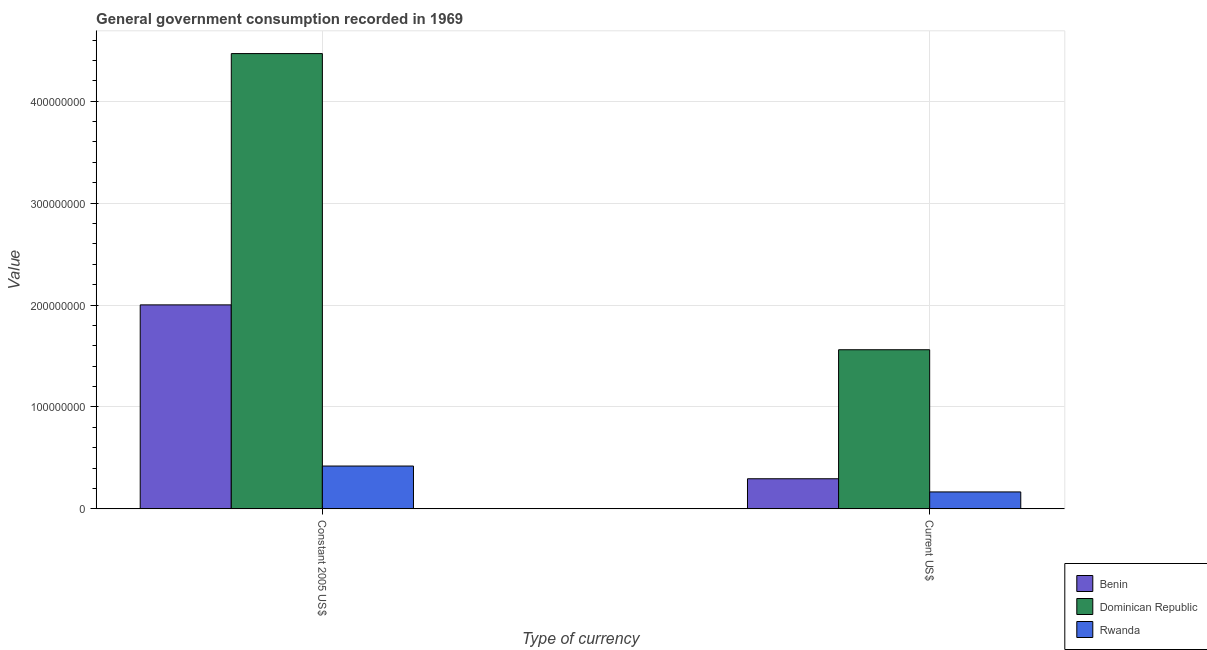How many different coloured bars are there?
Provide a short and direct response. 3. How many bars are there on the 2nd tick from the left?
Keep it short and to the point. 3. What is the label of the 1st group of bars from the left?
Ensure brevity in your answer.  Constant 2005 US$. What is the value consumed in current us$ in Dominican Republic?
Offer a terse response. 1.56e+08. Across all countries, what is the maximum value consumed in constant 2005 us$?
Ensure brevity in your answer.  4.47e+08. Across all countries, what is the minimum value consumed in current us$?
Give a very brief answer. 1.66e+07. In which country was the value consumed in constant 2005 us$ maximum?
Your response must be concise. Dominican Republic. In which country was the value consumed in current us$ minimum?
Keep it short and to the point. Rwanda. What is the total value consumed in current us$ in the graph?
Your response must be concise. 2.02e+08. What is the difference between the value consumed in constant 2005 us$ in Rwanda and that in Dominican Republic?
Keep it short and to the point. -4.05e+08. What is the difference between the value consumed in constant 2005 us$ in Rwanda and the value consumed in current us$ in Dominican Republic?
Your answer should be compact. -1.14e+08. What is the average value consumed in constant 2005 us$ per country?
Your answer should be compact. 2.30e+08. What is the difference between the value consumed in constant 2005 us$ and value consumed in current us$ in Benin?
Provide a short and direct response. 1.71e+08. What is the ratio of the value consumed in constant 2005 us$ in Benin to that in Dominican Republic?
Provide a short and direct response. 0.45. In how many countries, is the value consumed in constant 2005 us$ greater than the average value consumed in constant 2005 us$ taken over all countries?
Provide a succinct answer. 1. What does the 1st bar from the left in Current US$ represents?
Ensure brevity in your answer.  Benin. What does the 1st bar from the right in Constant 2005 US$ represents?
Keep it short and to the point. Rwanda. How many bars are there?
Ensure brevity in your answer.  6. Are the values on the major ticks of Y-axis written in scientific E-notation?
Your answer should be compact. No. Does the graph contain any zero values?
Your answer should be very brief. No. Does the graph contain grids?
Give a very brief answer. Yes. Where does the legend appear in the graph?
Keep it short and to the point. Bottom right. How many legend labels are there?
Ensure brevity in your answer.  3. What is the title of the graph?
Offer a terse response. General government consumption recorded in 1969. What is the label or title of the X-axis?
Offer a terse response. Type of currency. What is the label or title of the Y-axis?
Provide a short and direct response. Value. What is the Value of Benin in Constant 2005 US$?
Make the answer very short. 2.00e+08. What is the Value in Dominican Republic in Constant 2005 US$?
Provide a succinct answer. 4.47e+08. What is the Value in Rwanda in Constant 2005 US$?
Ensure brevity in your answer.  4.20e+07. What is the Value in Benin in Current US$?
Offer a terse response. 2.95e+07. What is the Value in Dominican Republic in Current US$?
Your answer should be very brief. 1.56e+08. What is the Value in Rwanda in Current US$?
Your answer should be compact. 1.66e+07. Across all Type of currency, what is the maximum Value in Benin?
Your answer should be compact. 2.00e+08. Across all Type of currency, what is the maximum Value in Dominican Republic?
Offer a very short reply. 4.47e+08. Across all Type of currency, what is the maximum Value in Rwanda?
Your response must be concise. 4.20e+07. Across all Type of currency, what is the minimum Value of Benin?
Provide a succinct answer. 2.95e+07. Across all Type of currency, what is the minimum Value in Dominican Republic?
Give a very brief answer. 1.56e+08. Across all Type of currency, what is the minimum Value in Rwanda?
Your response must be concise. 1.66e+07. What is the total Value in Benin in the graph?
Provide a succinct answer. 2.30e+08. What is the total Value in Dominican Republic in the graph?
Provide a short and direct response. 6.03e+08. What is the total Value of Rwanda in the graph?
Provide a short and direct response. 5.86e+07. What is the difference between the Value in Benin in Constant 2005 US$ and that in Current US$?
Your answer should be very brief. 1.71e+08. What is the difference between the Value of Dominican Republic in Constant 2005 US$ and that in Current US$?
Make the answer very short. 2.91e+08. What is the difference between the Value of Rwanda in Constant 2005 US$ and that in Current US$?
Give a very brief answer. 2.54e+07. What is the difference between the Value in Benin in Constant 2005 US$ and the Value in Dominican Republic in Current US$?
Provide a succinct answer. 4.40e+07. What is the difference between the Value in Benin in Constant 2005 US$ and the Value in Rwanda in Current US$?
Make the answer very short. 1.84e+08. What is the difference between the Value of Dominican Republic in Constant 2005 US$ and the Value of Rwanda in Current US$?
Offer a very short reply. 4.30e+08. What is the average Value of Benin per Type of currency?
Make the answer very short. 1.15e+08. What is the average Value in Dominican Republic per Type of currency?
Provide a succinct answer. 3.01e+08. What is the average Value in Rwanda per Type of currency?
Keep it short and to the point. 2.93e+07. What is the difference between the Value in Benin and Value in Dominican Republic in Constant 2005 US$?
Give a very brief answer. -2.47e+08. What is the difference between the Value of Benin and Value of Rwanda in Constant 2005 US$?
Keep it short and to the point. 1.58e+08. What is the difference between the Value in Dominican Republic and Value in Rwanda in Constant 2005 US$?
Ensure brevity in your answer.  4.05e+08. What is the difference between the Value in Benin and Value in Dominican Republic in Current US$?
Offer a terse response. -1.27e+08. What is the difference between the Value of Benin and Value of Rwanda in Current US$?
Offer a terse response. 1.29e+07. What is the difference between the Value in Dominican Republic and Value in Rwanda in Current US$?
Provide a succinct answer. 1.39e+08. What is the ratio of the Value in Benin in Constant 2005 US$ to that in Current US$?
Ensure brevity in your answer.  6.78. What is the ratio of the Value of Dominican Republic in Constant 2005 US$ to that in Current US$?
Offer a terse response. 2.86. What is the ratio of the Value of Rwanda in Constant 2005 US$ to that in Current US$?
Keep it short and to the point. 2.53. What is the difference between the highest and the second highest Value in Benin?
Keep it short and to the point. 1.71e+08. What is the difference between the highest and the second highest Value of Dominican Republic?
Provide a succinct answer. 2.91e+08. What is the difference between the highest and the second highest Value of Rwanda?
Keep it short and to the point. 2.54e+07. What is the difference between the highest and the lowest Value in Benin?
Make the answer very short. 1.71e+08. What is the difference between the highest and the lowest Value in Dominican Republic?
Your answer should be compact. 2.91e+08. What is the difference between the highest and the lowest Value in Rwanda?
Offer a terse response. 2.54e+07. 